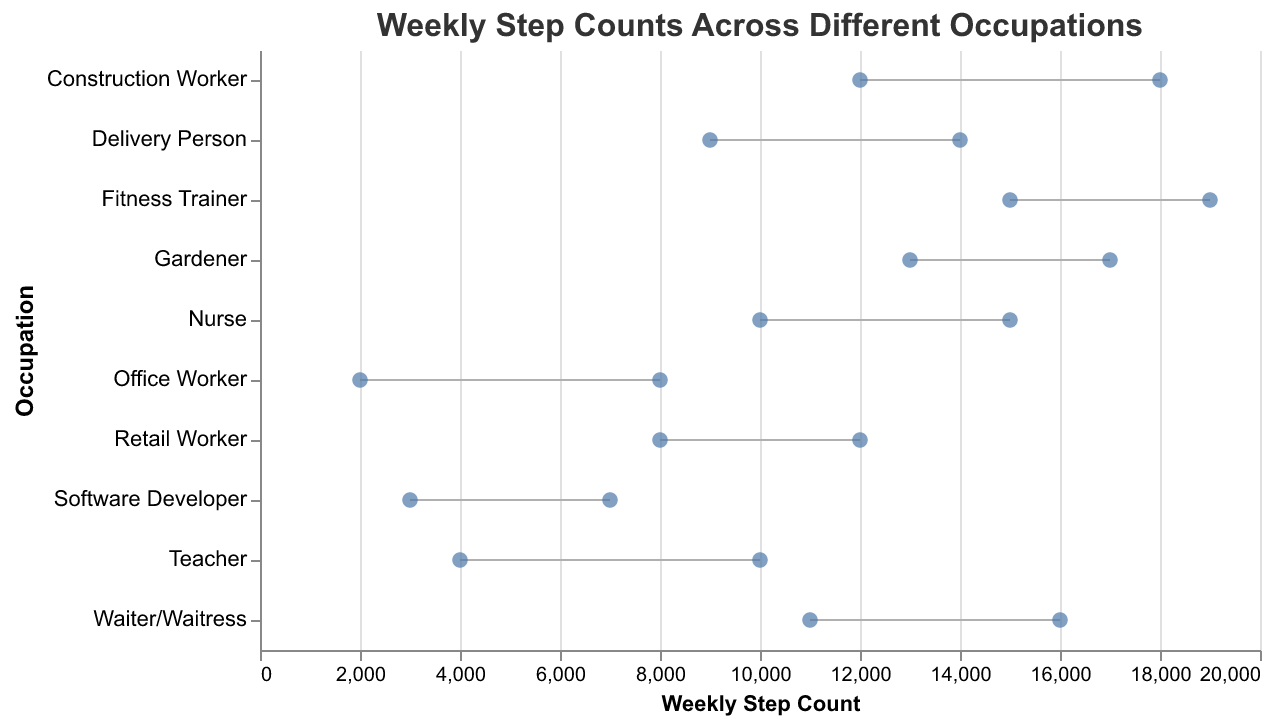What is the title of the figure? The title of the figure is displayed at the top of the chart.
Answer: Weekly Step Counts Across Different Occupations What is the minimum number of steps taken by a Software Developer in a week? The minimum number of steps for each occupation is shown by the starting point of the line at the left side. For Software Developers, it starts at 3000.
Answer: 3000 Which occupation has the highest maximum step count in a week? The highest maximum step count is indicated by the end of the line furthest to the right. Fitness Trainer has its line ending at 19000 steps, which is the highest.
Answer: Fitness Trainer How many occupations have a maximum step count of at least 15000 steps in a week? To find this, check the endpoint of the lines for each occupation and count those which end at or beyond 15000 steps. These occupations are Nurse, Waiter/Waitress, Fitness Trainer, and Gardener. So there are four such occupations.
Answer: 4 What is the difference in the maximum step count between a Nurse and a Waiter/Waitress? Locate the maximum step count for both occupations. For Nurses it's 15000, and for Waiter/Waitress it's 16000. Subtract the smaller value from the larger one: 16000 - 15000 = 1000 steps.
Answer: 1000 steps What is the range of steps for a Teacher? The range is calculated by subtracting the minimum step count from the maximum step count. For Teachers, the range is 10000 - 4000 = 6000 steps.
Answer: 6000 steps Which occupation has the narrowest range of step counts? The narrowest range is determined by the shortest line. Compare the lengths of the lines to see that Software Developer ranges from 3000 to 7000 steps, a range of 4000 steps. This is the smallest range in the plot.
Answer: Software Developer How do the minimum steps for a Gardener compare to the maximum steps for a Retail Worker? The minimum steps for a Gardener are 13000, while the maximum steps for a Retail Worker are 12000. Therefore, a Gardener's minimum is greater than a Retail Worker's maximum.
Answer: Greater than If the maximum step counts for all occupations were increased by 1000, what would be the new maximum step count for a Delivery Person? The current maximum step count for a Delivery Person is 14000. Adding 1000 to this value results in a new maximum of 15000 steps.
Answer: 15000 steps 